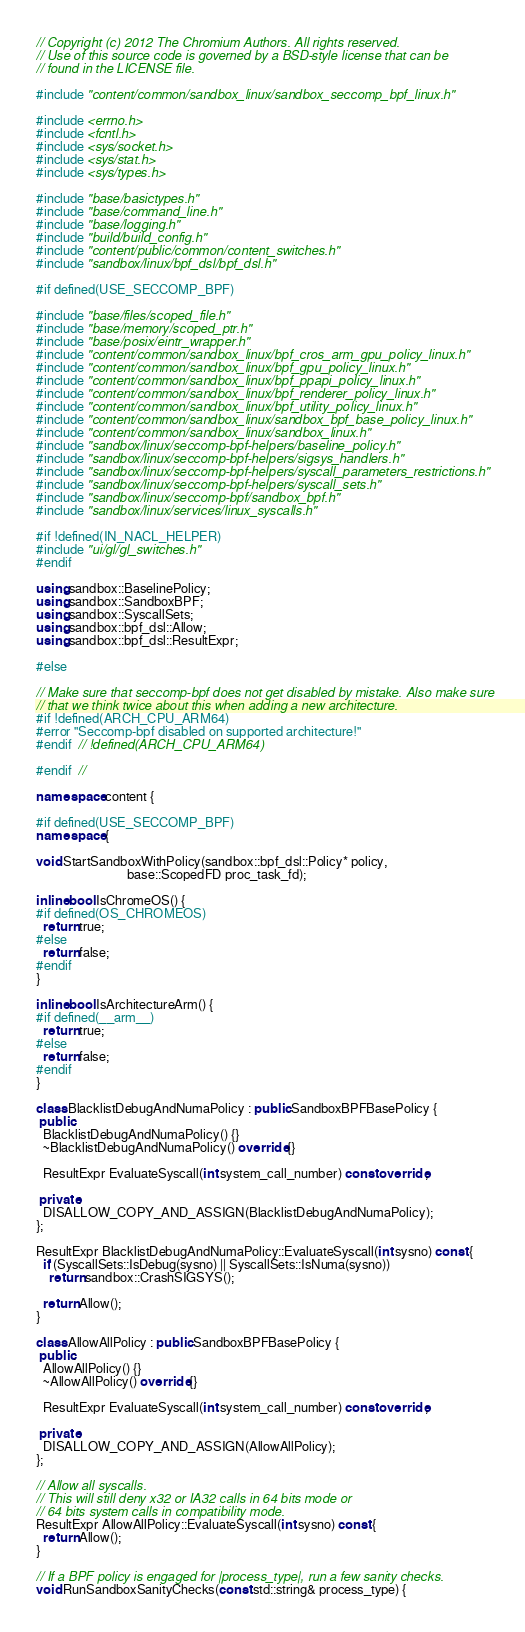<code> <loc_0><loc_0><loc_500><loc_500><_C++_>// Copyright (c) 2012 The Chromium Authors. All rights reserved.
// Use of this source code is governed by a BSD-style license that can be
// found in the LICENSE file.

#include "content/common/sandbox_linux/sandbox_seccomp_bpf_linux.h"

#include <errno.h>
#include <fcntl.h>
#include <sys/socket.h>
#include <sys/stat.h>
#include <sys/types.h>

#include "base/basictypes.h"
#include "base/command_line.h"
#include "base/logging.h"
#include "build/build_config.h"
#include "content/public/common/content_switches.h"
#include "sandbox/linux/bpf_dsl/bpf_dsl.h"

#if defined(USE_SECCOMP_BPF)

#include "base/files/scoped_file.h"
#include "base/memory/scoped_ptr.h"
#include "base/posix/eintr_wrapper.h"
#include "content/common/sandbox_linux/bpf_cros_arm_gpu_policy_linux.h"
#include "content/common/sandbox_linux/bpf_gpu_policy_linux.h"
#include "content/common/sandbox_linux/bpf_ppapi_policy_linux.h"
#include "content/common/sandbox_linux/bpf_renderer_policy_linux.h"
#include "content/common/sandbox_linux/bpf_utility_policy_linux.h"
#include "content/common/sandbox_linux/sandbox_bpf_base_policy_linux.h"
#include "content/common/sandbox_linux/sandbox_linux.h"
#include "sandbox/linux/seccomp-bpf-helpers/baseline_policy.h"
#include "sandbox/linux/seccomp-bpf-helpers/sigsys_handlers.h"
#include "sandbox/linux/seccomp-bpf-helpers/syscall_parameters_restrictions.h"
#include "sandbox/linux/seccomp-bpf-helpers/syscall_sets.h"
#include "sandbox/linux/seccomp-bpf/sandbox_bpf.h"
#include "sandbox/linux/services/linux_syscalls.h"

#if !defined(IN_NACL_HELPER)
#include "ui/gl/gl_switches.h"
#endif

using sandbox::BaselinePolicy;
using sandbox::SandboxBPF;
using sandbox::SyscallSets;
using sandbox::bpf_dsl::Allow;
using sandbox::bpf_dsl::ResultExpr;

#else

// Make sure that seccomp-bpf does not get disabled by mistake. Also make sure
// that we think twice about this when adding a new architecture.
#if !defined(ARCH_CPU_ARM64)
#error "Seccomp-bpf disabled on supported architecture!"
#endif  // !defined(ARCH_CPU_ARM64)

#endif  //

namespace content {

#if defined(USE_SECCOMP_BPF)
namespace {

void StartSandboxWithPolicy(sandbox::bpf_dsl::Policy* policy,
                            base::ScopedFD proc_task_fd);

inline bool IsChromeOS() {
#if defined(OS_CHROMEOS)
  return true;
#else
  return false;
#endif
}

inline bool IsArchitectureArm() {
#if defined(__arm__)
  return true;
#else
  return false;
#endif
}

class BlacklistDebugAndNumaPolicy : public SandboxBPFBasePolicy {
 public:
  BlacklistDebugAndNumaPolicy() {}
  ~BlacklistDebugAndNumaPolicy() override {}

  ResultExpr EvaluateSyscall(int system_call_number) const override;

 private:
  DISALLOW_COPY_AND_ASSIGN(BlacklistDebugAndNumaPolicy);
};

ResultExpr BlacklistDebugAndNumaPolicy::EvaluateSyscall(int sysno) const {
  if (SyscallSets::IsDebug(sysno) || SyscallSets::IsNuma(sysno))
    return sandbox::CrashSIGSYS();

  return Allow();
}

class AllowAllPolicy : public SandboxBPFBasePolicy {
 public:
  AllowAllPolicy() {}
  ~AllowAllPolicy() override {}

  ResultExpr EvaluateSyscall(int system_call_number) const override;

 private:
  DISALLOW_COPY_AND_ASSIGN(AllowAllPolicy);
};

// Allow all syscalls.
// This will still deny x32 or IA32 calls in 64 bits mode or
// 64 bits system calls in compatibility mode.
ResultExpr AllowAllPolicy::EvaluateSyscall(int sysno) const {
  return Allow();
}

// If a BPF policy is engaged for |process_type|, run a few sanity checks.
void RunSandboxSanityChecks(const std::string& process_type) {</code> 